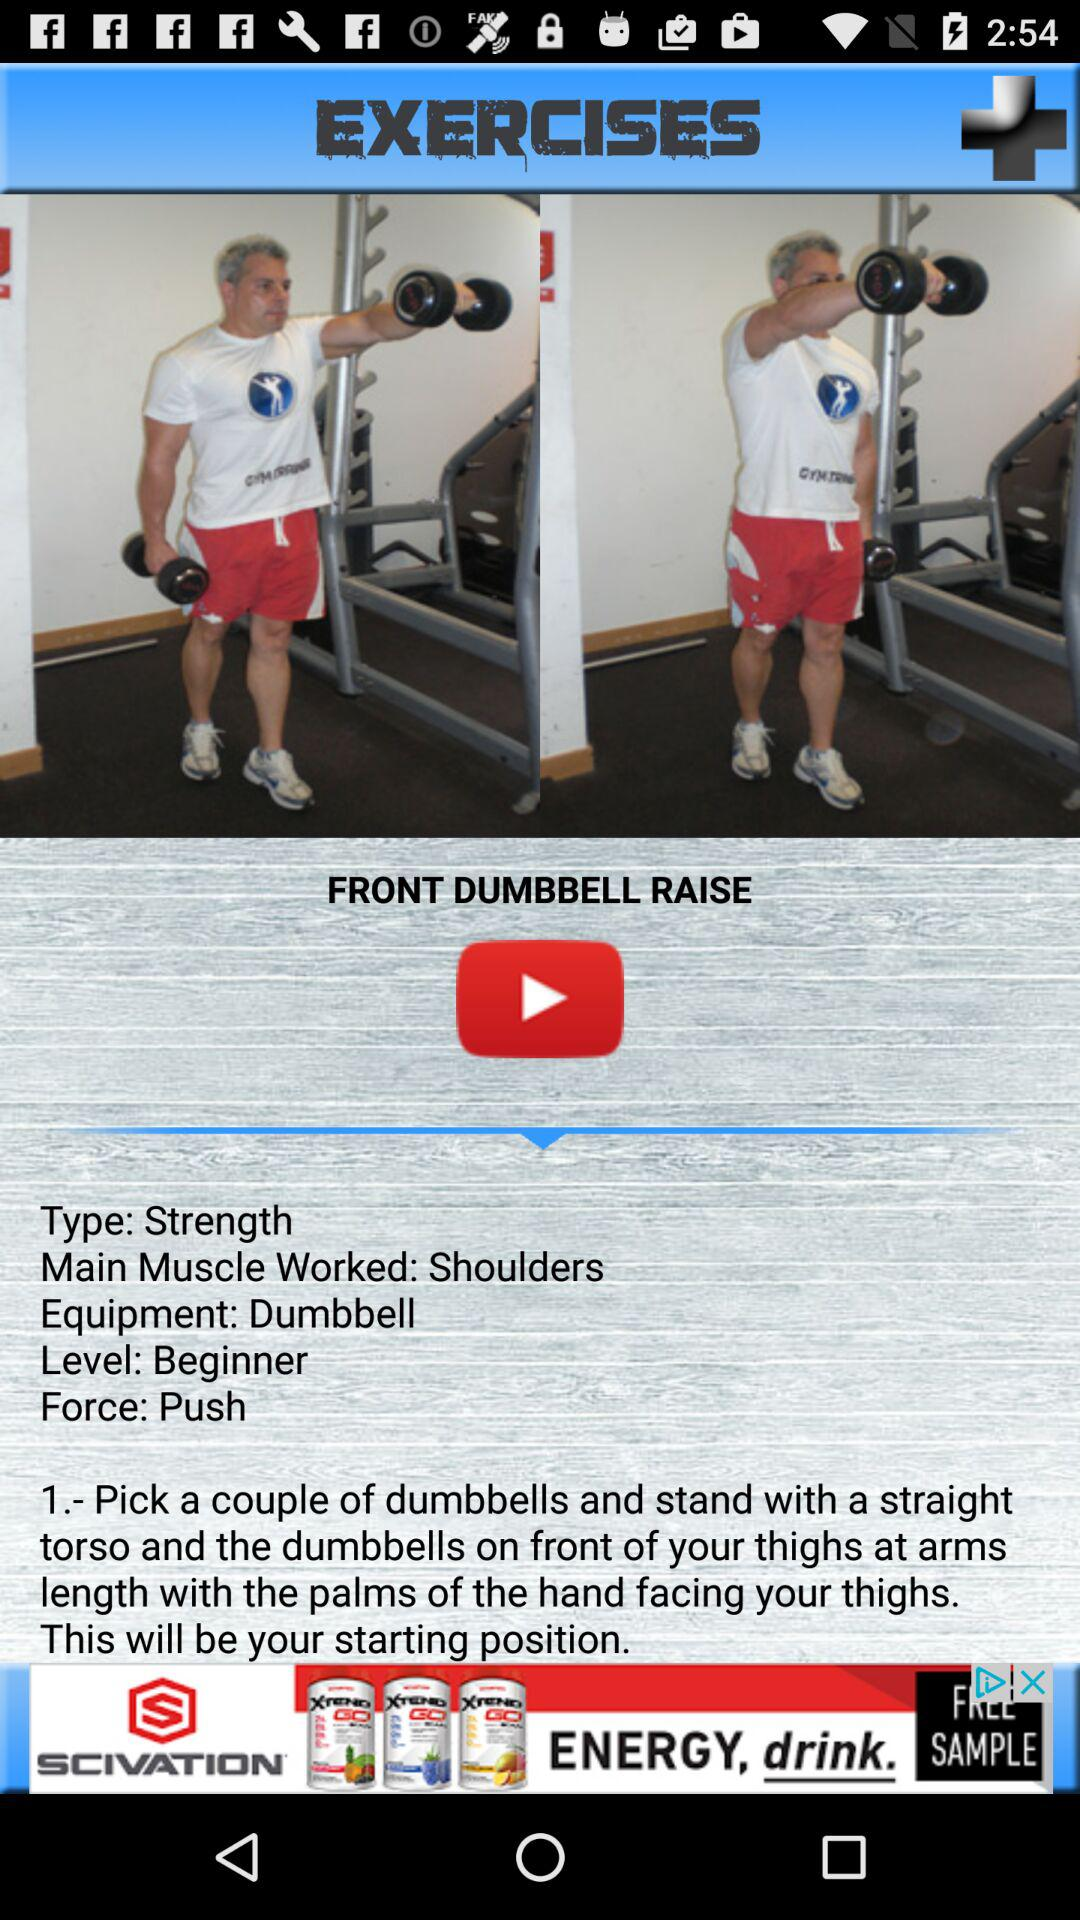What is the type of the "FRONT DUMBBELL RAISE" exercise? The type is "Strength". 